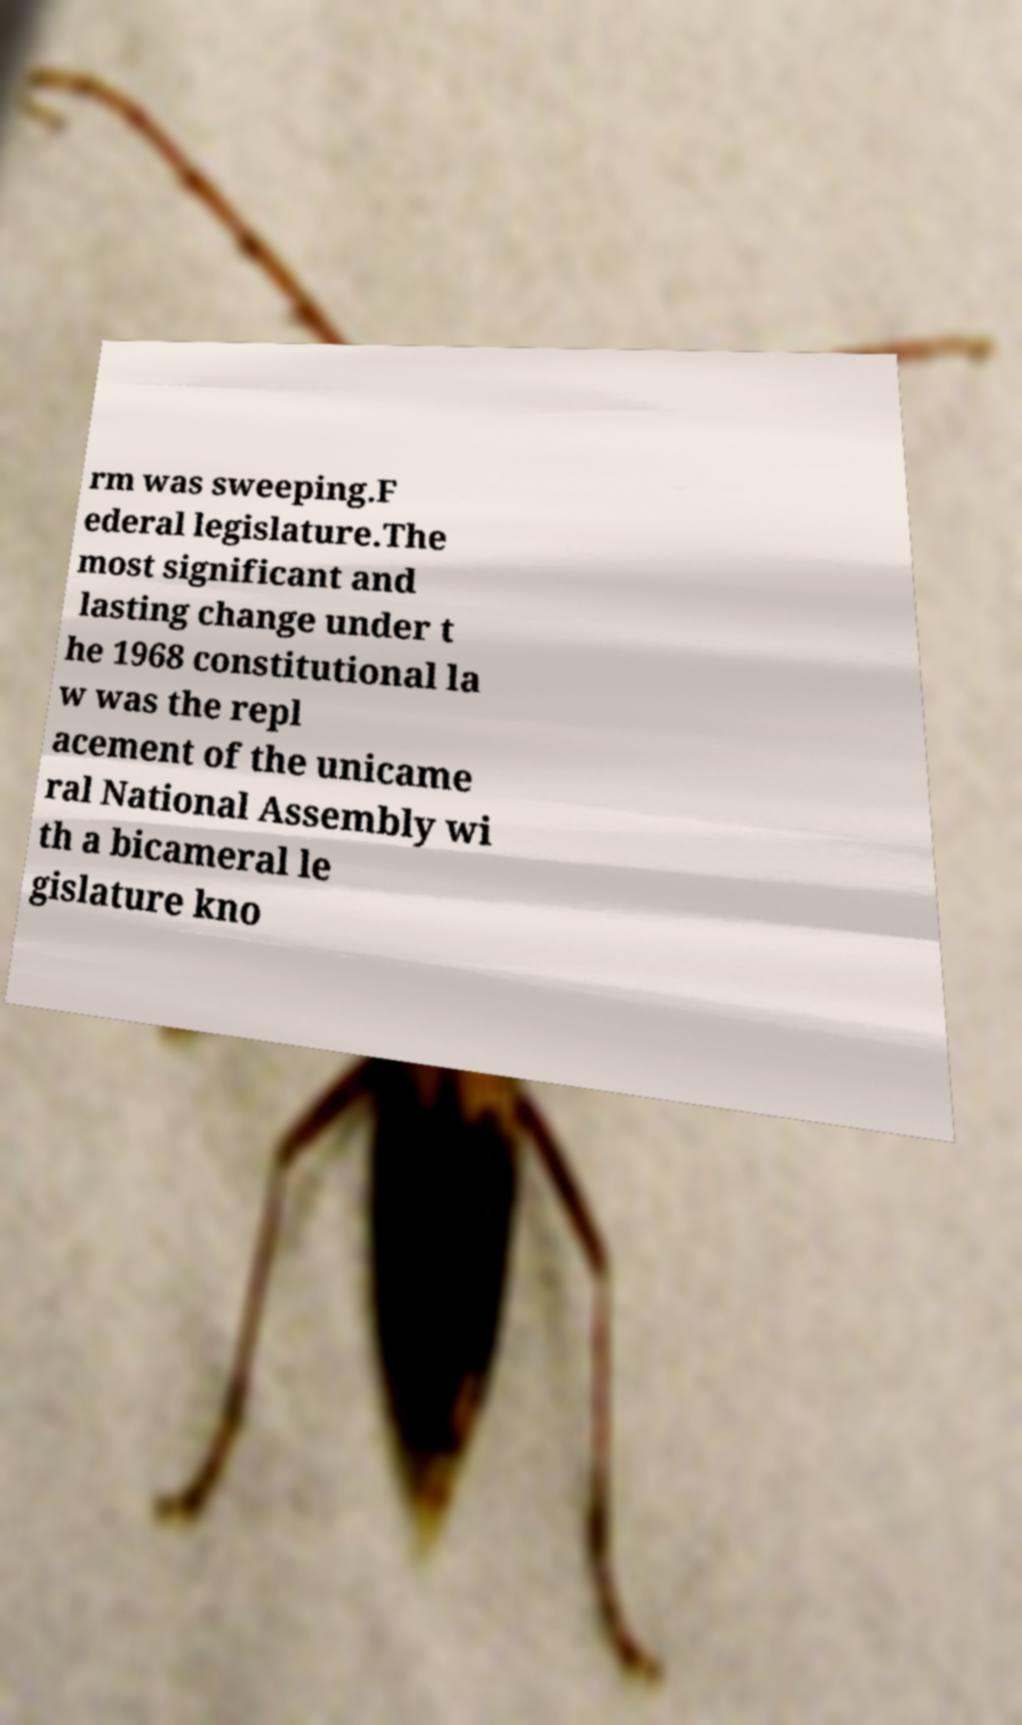Could you assist in decoding the text presented in this image and type it out clearly? rm was sweeping.F ederal legislature.The most significant and lasting change under t he 1968 constitutional la w was the repl acement of the unicame ral National Assembly wi th a bicameral le gislature kno 